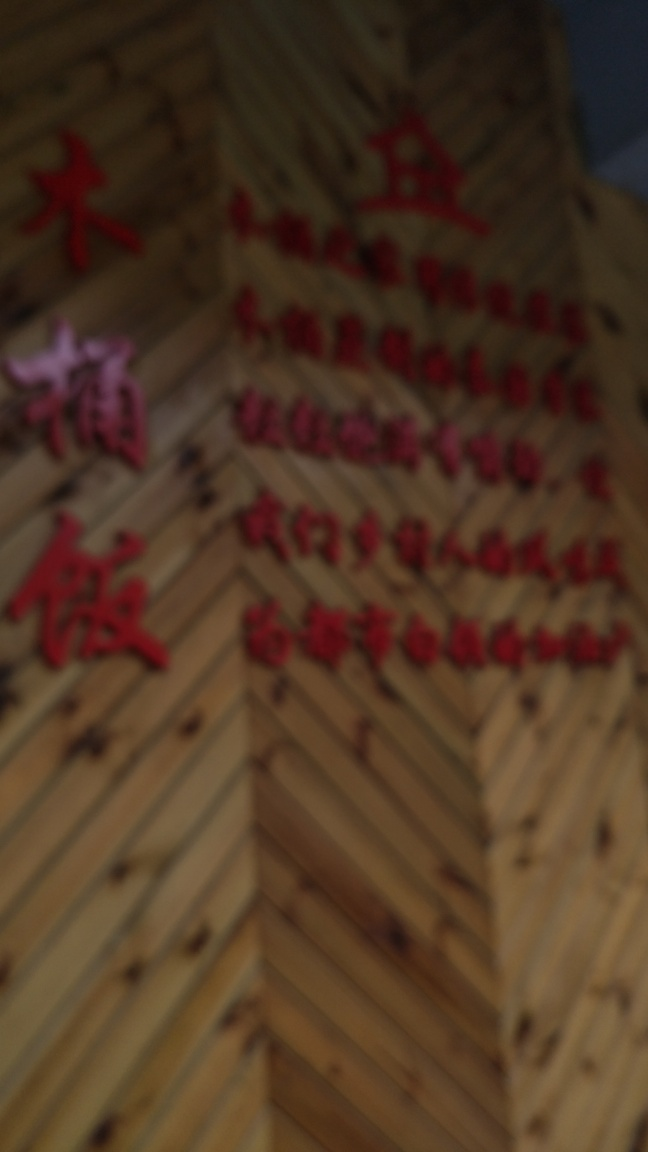How can one improve the quality of an image like this? To improve the quality of such an image, retaking the photo with a steady hand or a tripod, using a camera with higher resolution and proper focus settings is advised. If retaking the image isn't an option, post-processing with image editing software like Photoshop might enhance clarity to some extent, but it would be limited by the original image quality. 